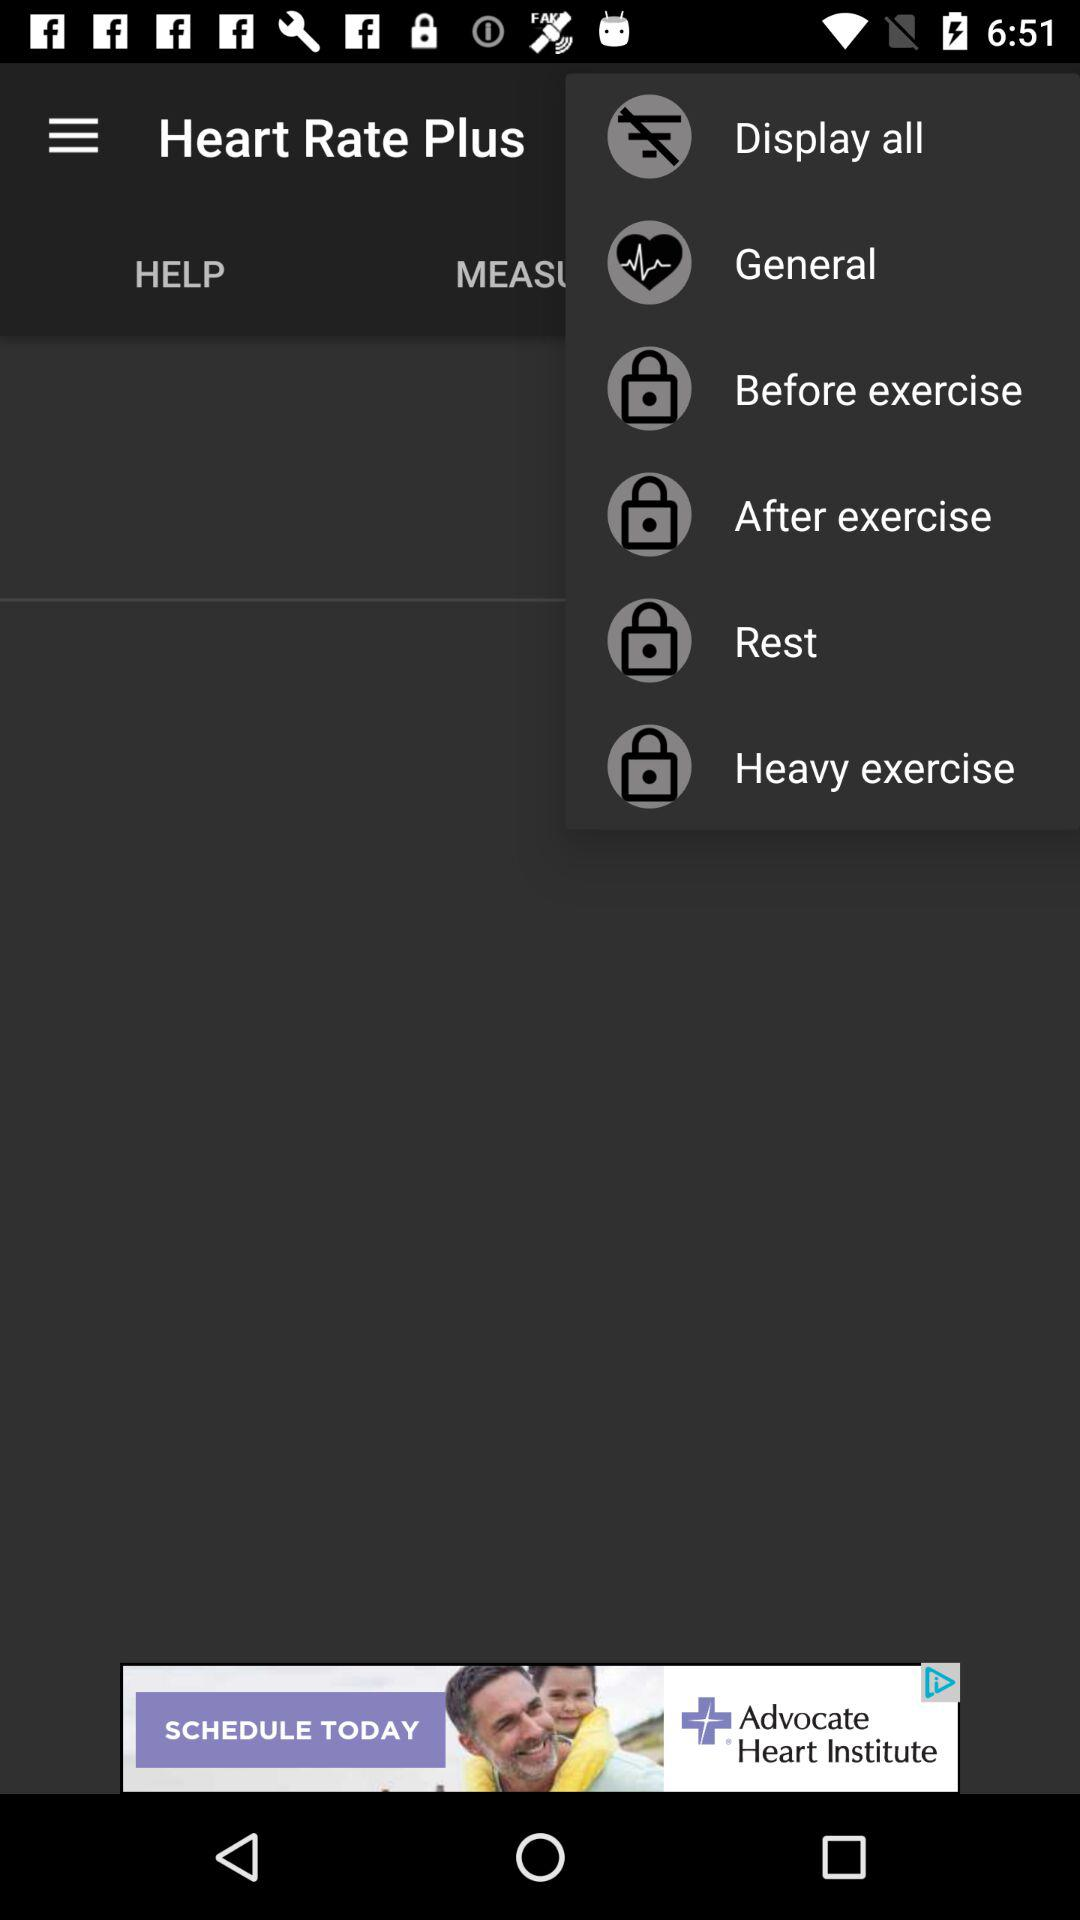What is the application name? The application name is "Heart Rate Plus". 